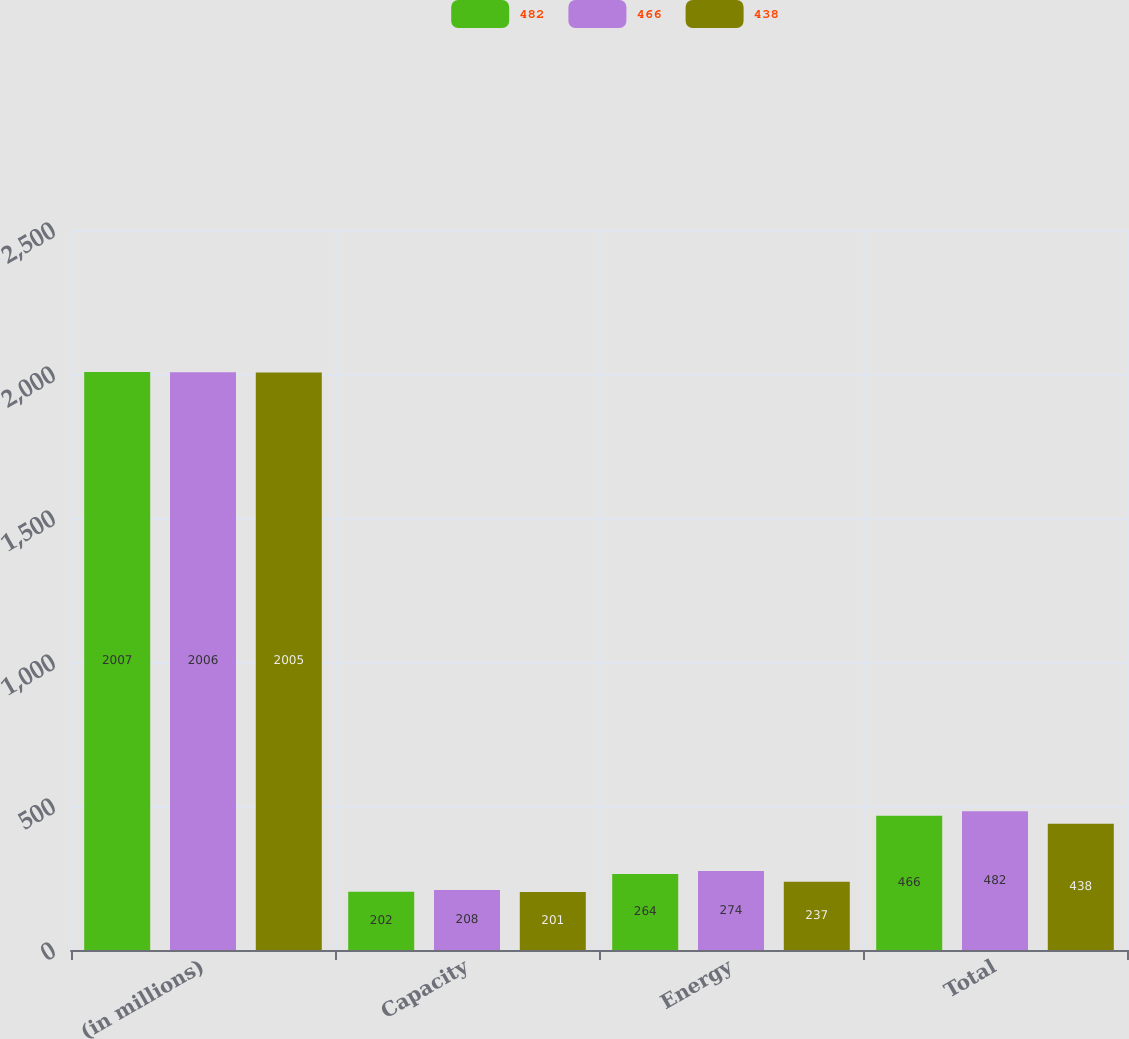Convert chart to OTSL. <chart><loc_0><loc_0><loc_500><loc_500><stacked_bar_chart><ecel><fcel>(in millions)<fcel>Capacity<fcel>Energy<fcel>Total<nl><fcel>482<fcel>2007<fcel>202<fcel>264<fcel>466<nl><fcel>466<fcel>2006<fcel>208<fcel>274<fcel>482<nl><fcel>438<fcel>2005<fcel>201<fcel>237<fcel>438<nl></chart> 